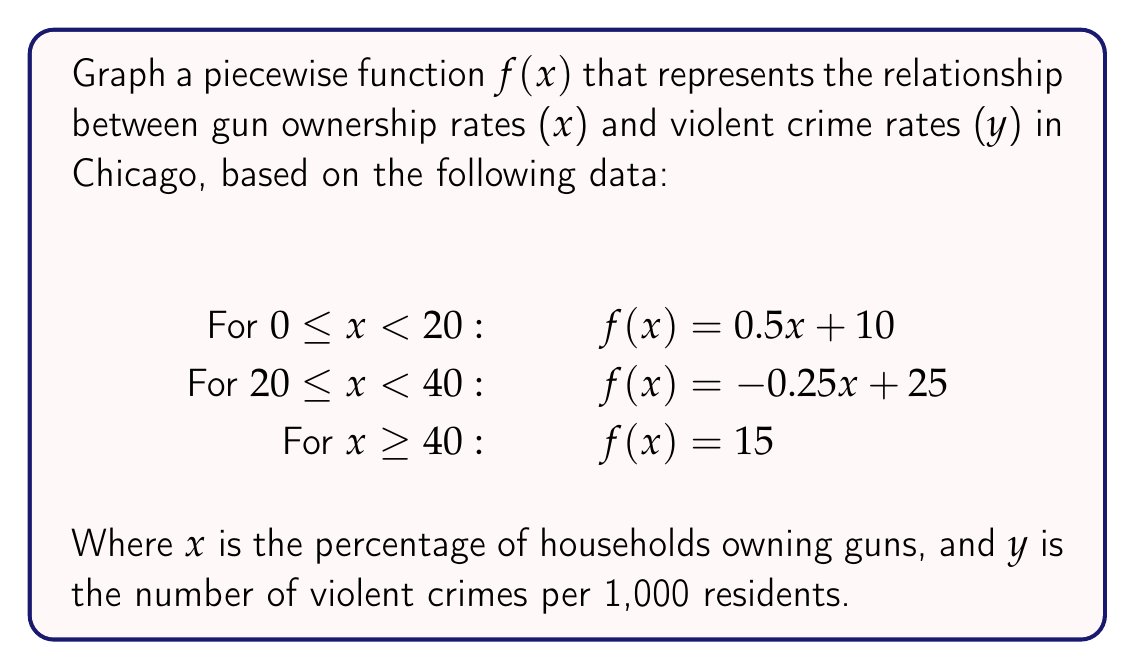Help me with this question. To graph this piecewise function, we'll follow these steps:

1. Identify the three pieces of the function:
   a. $f(x) = 0.5x + 10$ for $0 \leq x < 20$
   b. $f(x) = -0.25x + 25$ for $20 \leq x < 40$
   c. $f(x) = 15$ for $x \geq 40$

2. Plot key points for each piece:
   a. For $0 \leq x < 20$:
      - At $x = 0$: $y = 0.5(0) + 10 = 10$
      - At $x = 20$: $y = 0.5(20) + 10 = 20$
   b. For $20 \leq x < 40$:
      - At $x = 20$: $y = -0.25(20) + 25 = 20$
      - At $x = 40$: $y = -0.25(40) + 25 = 15$
   c. For $x \geq 40$:
      - Constant function at $y = 15$

3. Draw the graph:
   - Plot the points identified in step 2
   - Connect the points with line segments for the first two pieces
   - Draw a horizontal line at $y = 15$ for $x \geq 40$
   - Use open circles at $x = 20$ and $x = 40$ to show the function is continuous but not differentiable at these points

4. Label the axes:
   - x-axis: "Gun Ownership Rate (%)"
   - y-axis: "Violent Crime Rate (per 1,000 residents)"

[asy]
import graph;
size(200,150);

real f(real x) {
  if (x < 20) return 0.5x + 10;
  if (x < 40) return -0.25x + 25;
  return 15;
}

draw(graph(f,0,60),red);

xaxis("Gun Ownership Rate (%)",axis=BottomTop,Ticks);
yaxis("Violent Crime Rate (per 1,000 residents)",axis=LeftRight,Ticks);

dot((20,20),white);
dot((40,15),white);
[/asy]
Answer: The graph shows an increasing crime rate for gun ownership 0-20%, decreasing for 20-40%, and constant for >40%. 